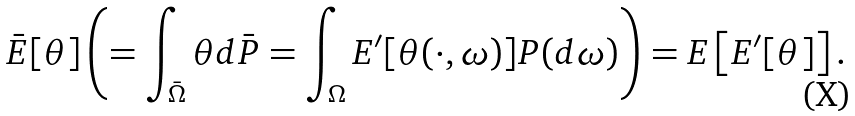<formula> <loc_0><loc_0><loc_500><loc_500>\bar { E } [ \theta ] \left ( = \int _ { \bar { \Omega } } \theta d \bar { P } = \int _ { \Omega } E ^ { \prime } [ \theta ( \cdot , \omega ) ] P ( d \omega ) \right ) = E \left [ E ^ { \prime } [ \theta ] \right ] .</formula> 